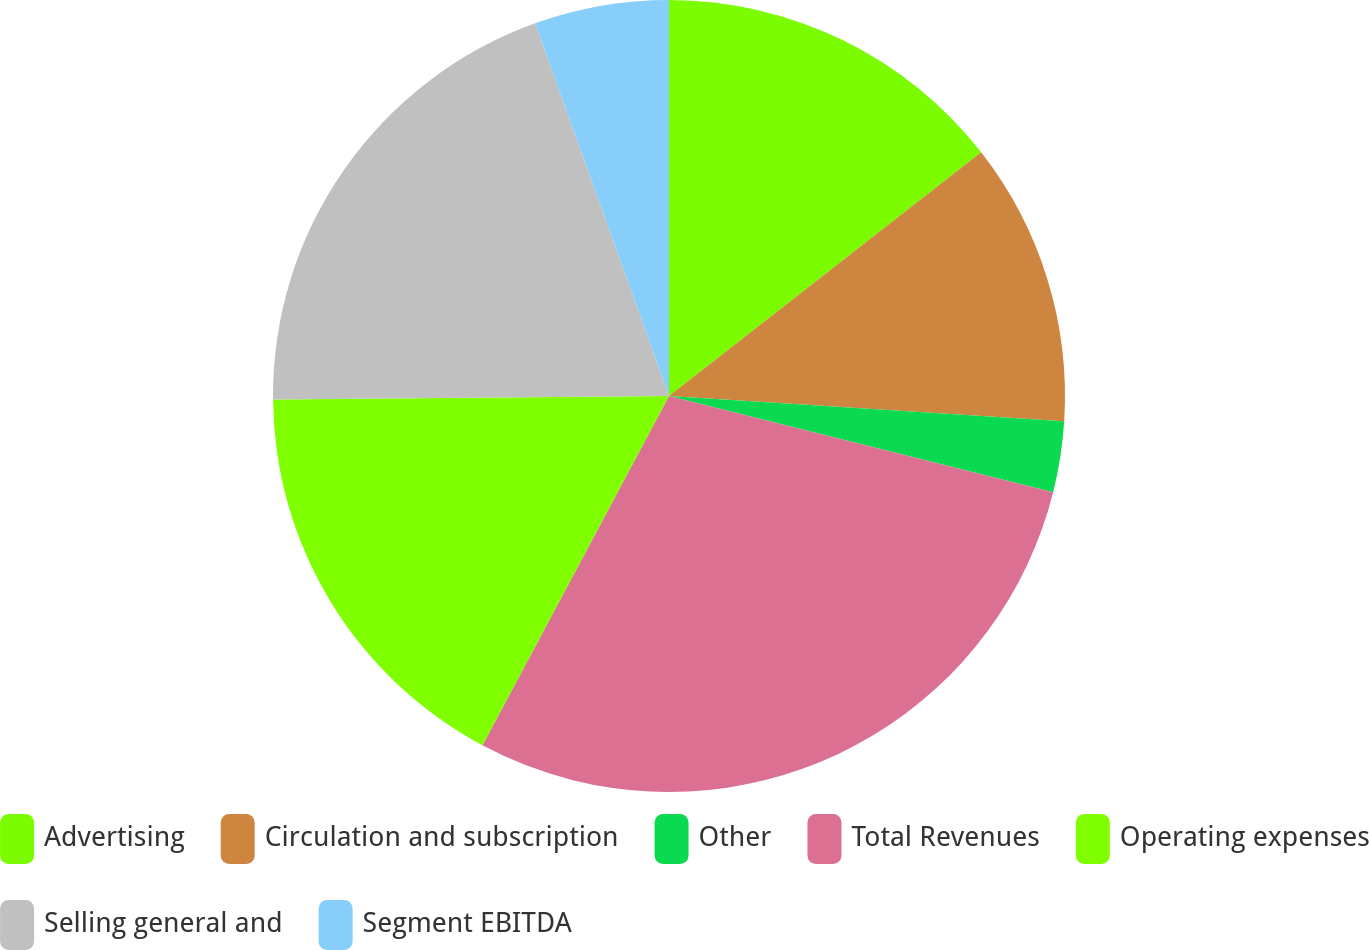Convert chart. <chart><loc_0><loc_0><loc_500><loc_500><pie_chart><fcel>Advertising<fcel>Circulation and subscription<fcel>Other<fcel>Total Revenues<fcel>Operating expenses<fcel>Selling general and<fcel>Segment EBITDA<nl><fcel>14.45%<fcel>11.56%<fcel>2.89%<fcel>28.9%<fcel>17.05%<fcel>19.65%<fcel>5.49%<nl></chart> 